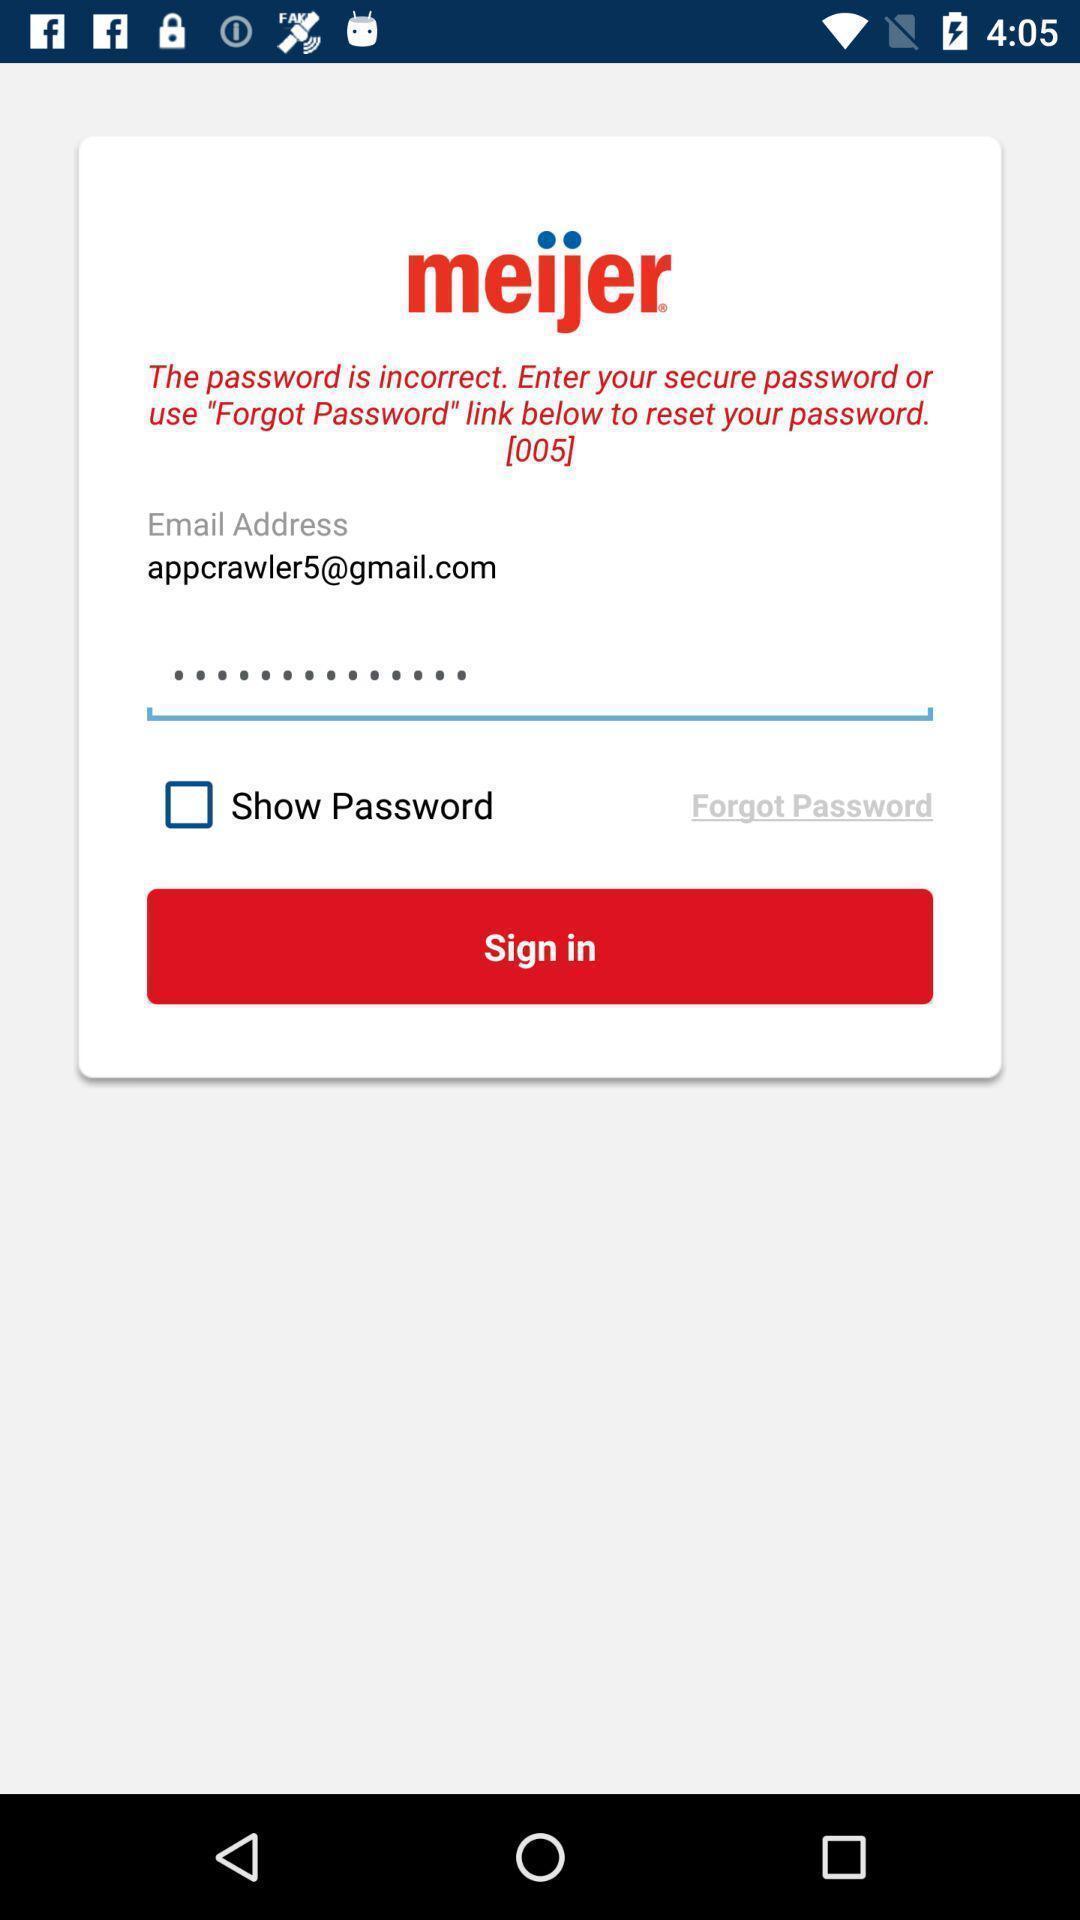Tell me about the visual elements in this screen capture. Sign-in page. 